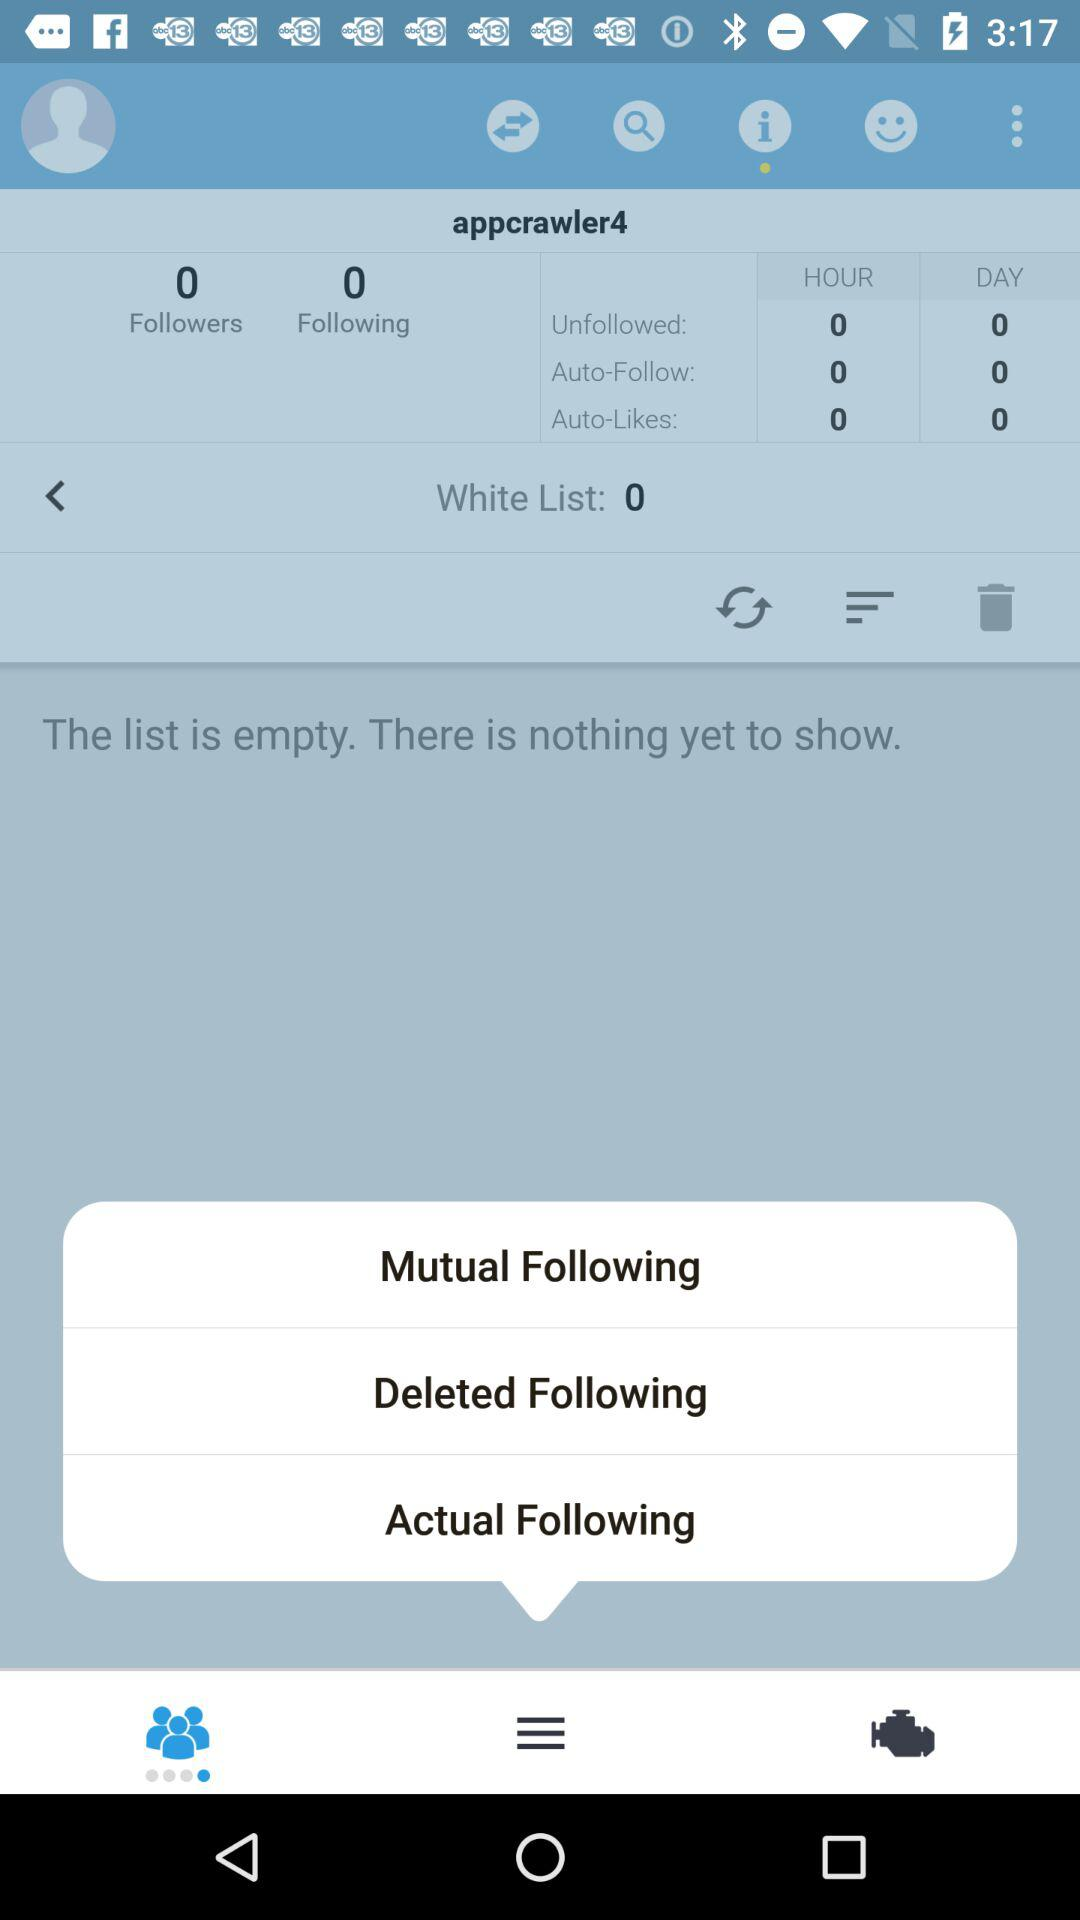What is the count of white list?
Answer the question using a single word or phrase. The count of white list is 0 